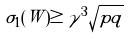<formula> <loc_0><loc_0><loc_500><loc_500>\sigma _ { 1 } ( W ) \geq \gamma ^ { 3 } \sqrt { p q }</formula> 